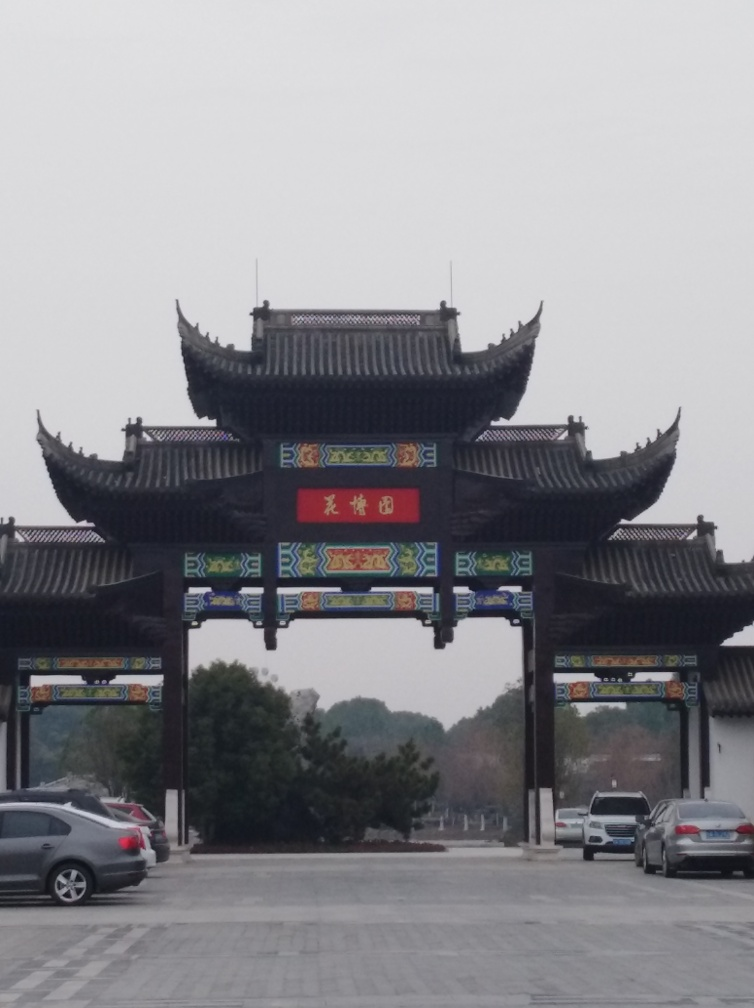What does the signage in the image indicate? Although specific details can't be discerned due to the image's quality, typically, such signs display the name of the site, its historical significance, or an auspicious greeting. They are often painted in vibrant colors, with gold often used to symbolize wealth and fortune. 